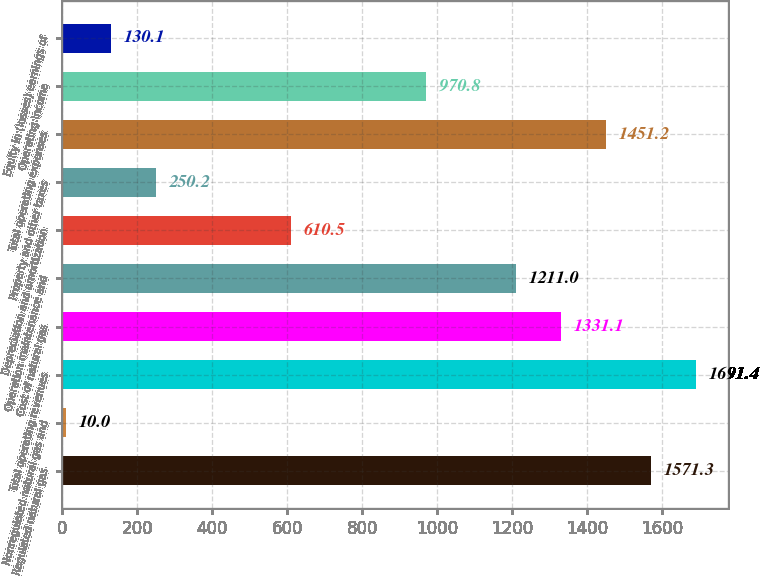Convert chart to OTSL. <chart><loc_0><loc_0><loc_500><loc_500><bar_chart><fcel>Regulated natural gas<fcel>Nonregulated natural gas and<fcel>Total operating revenues<fcel>Cost of natural gas<fcel>Operation maintenance and<fcel>Depreciation and amortization<fcel>Property and other taxes<fcel>Total operating expenses<fcel>Operating Income<fcel>Equity in (losses) earnings of<nl><fcel>1571.3<fcel>10<fcel>1691.4<fcel>1331.1<fcel>1211<fcel>610.5<fcel>250.2<fcel>1451.2<fcel>970.8<fcel>130.1<nl></chart> 